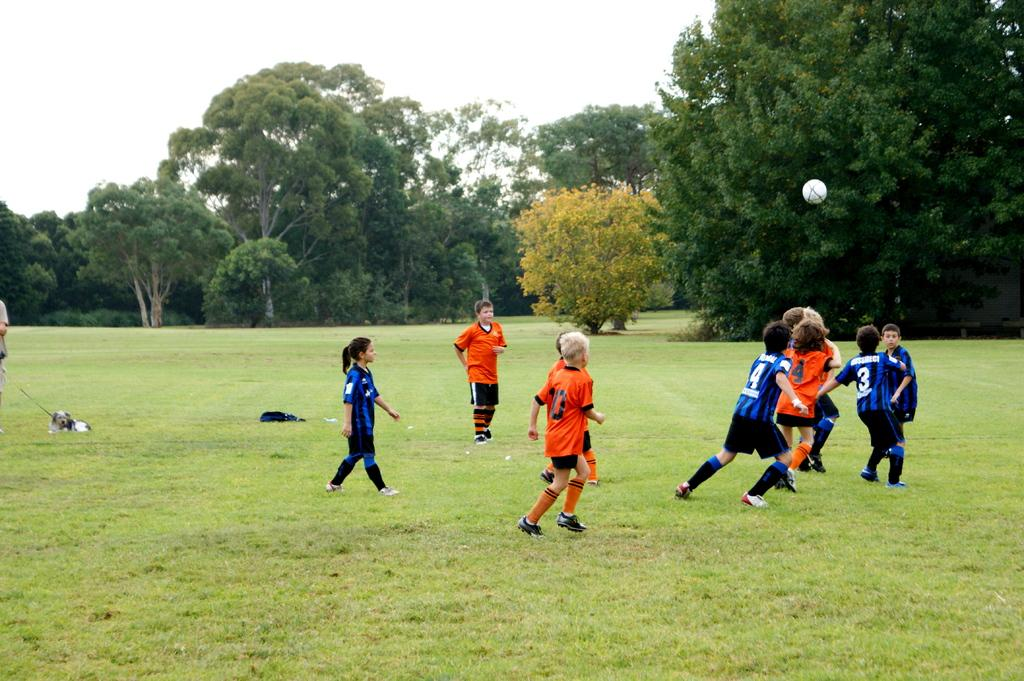What are the children in the image doing? The children are playing in the image. Where are the children playing? The children are playing in a garden. What can be seen in the background of the image? There are trees in the background of the image. What type of hook can be seen in the image? There is no hook present in the image. What kind of flowers are growing in the garden in the image? The provided facts do not mention any flowers in the garden, so we cannot determine the type of flowers present. 